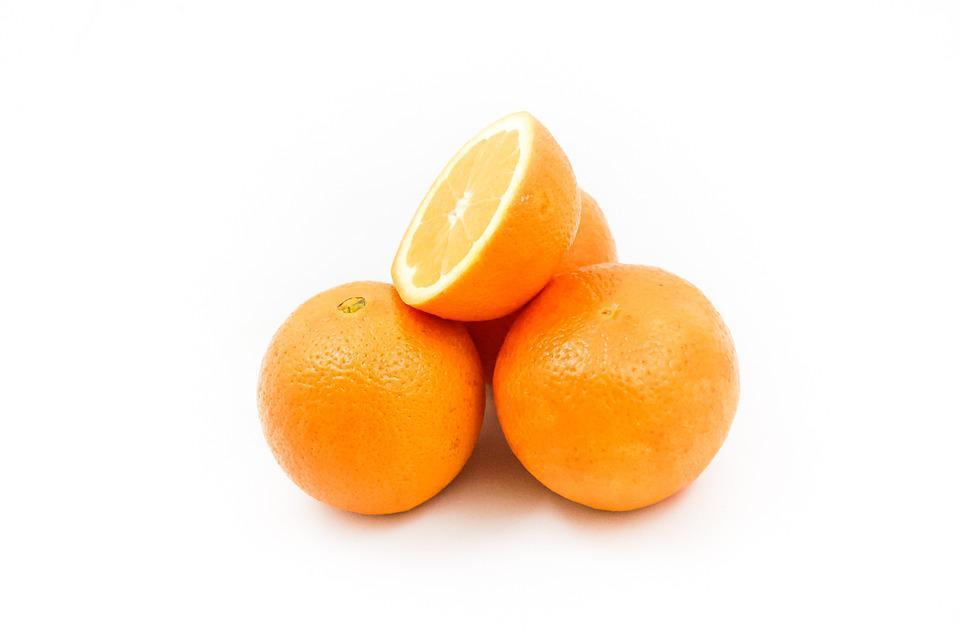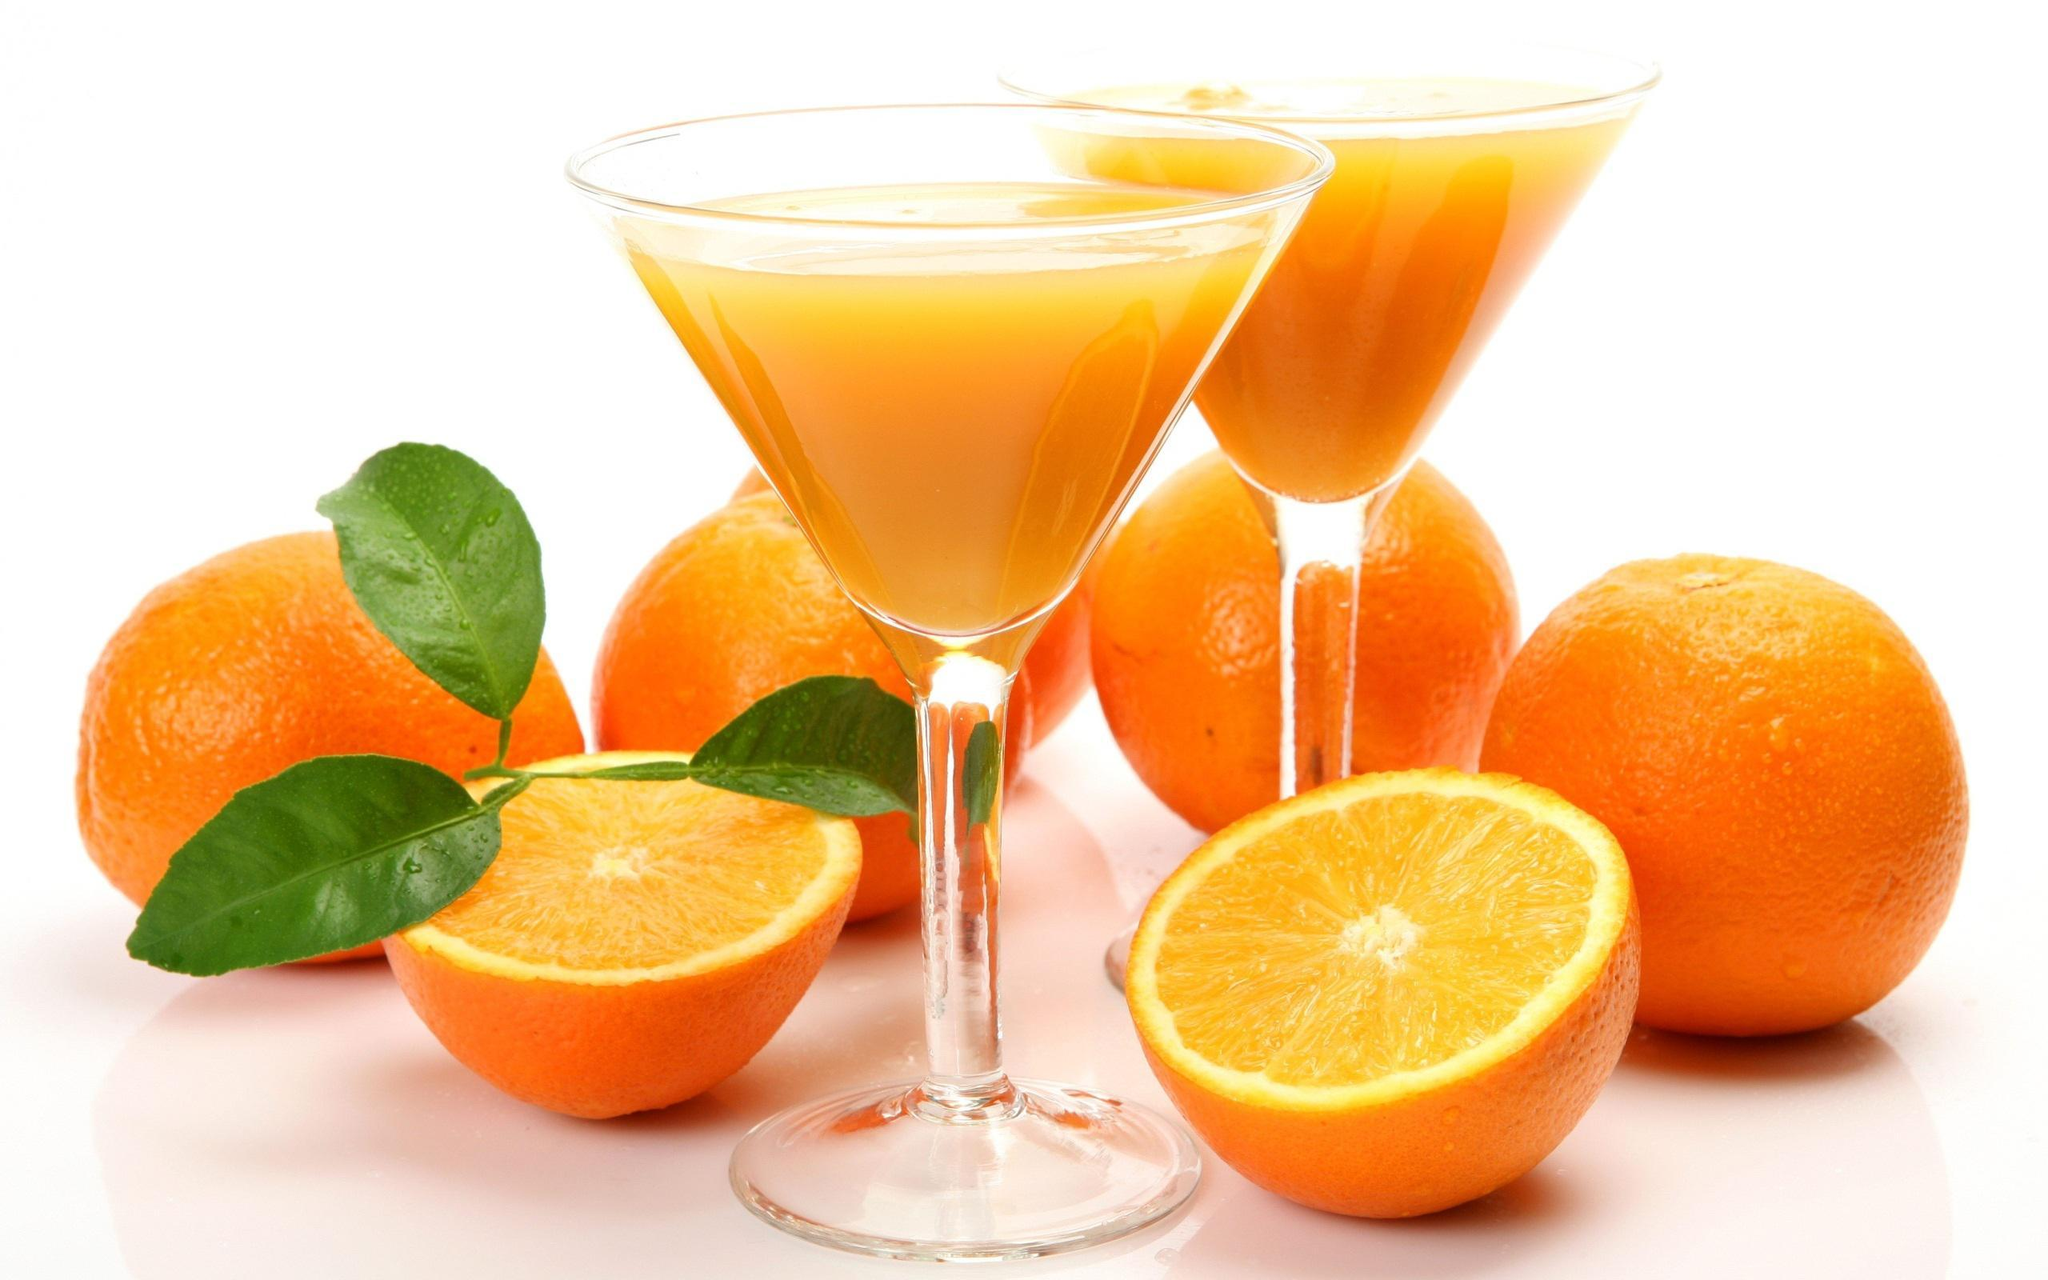The first image is the image on the left, the second image is the image on the right. Assess this claim about the two images: "Some of the oranges are cut into wedges, not just halves.". Correct or not? Answer yes or no. No. The first image is the image on the left, the second image is the image on the right. Analyze the images presented: Is the assertion "Only one image contains the juice of the oranges." valid? Answer yes or no. Yes. 